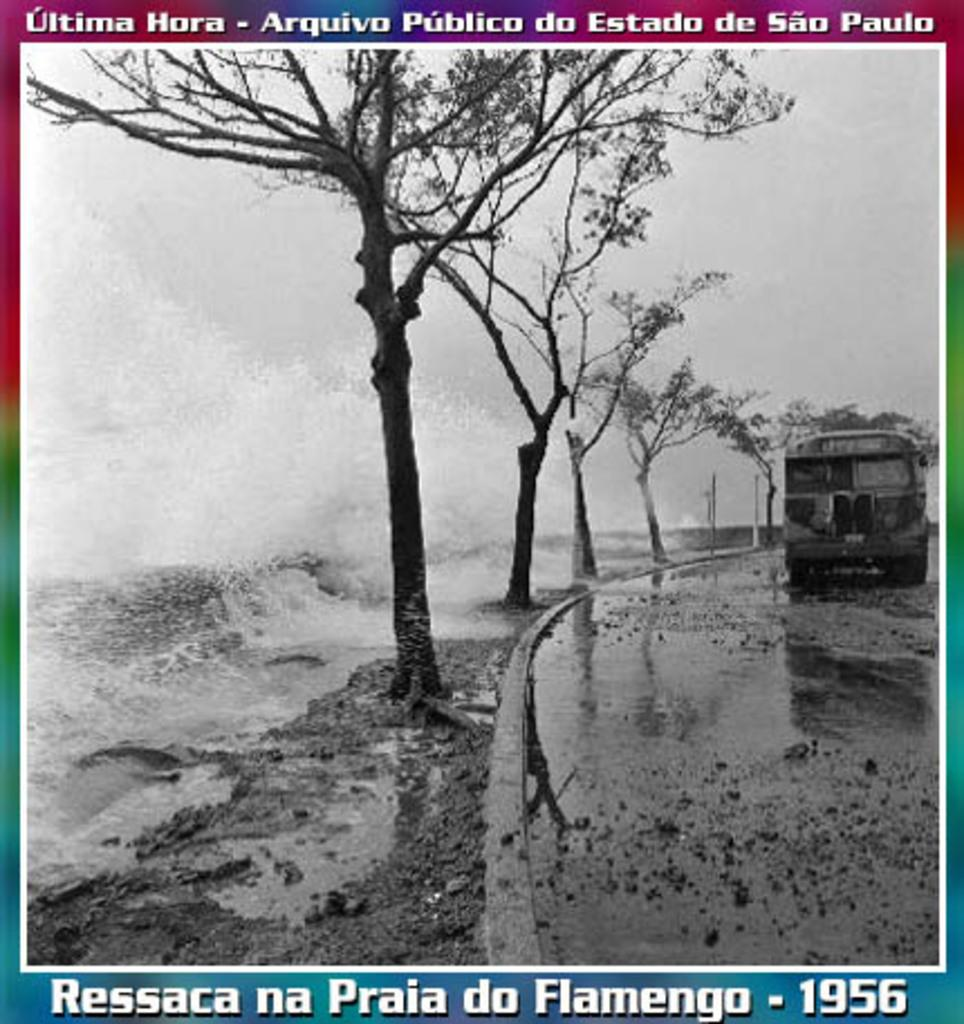<image>
Share a concise interpretation of the image provided. Poster which shows a bus on a street and the year 1956. 